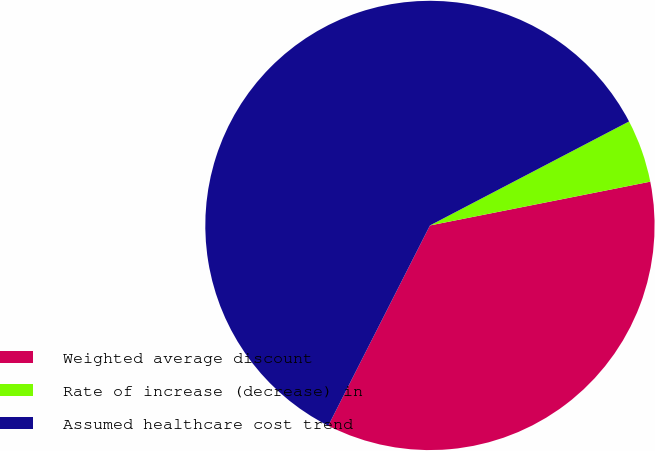Convert chart. <chart><loc_0><loc_0><loc_500><loc_500><pie_chart><fcel>Weighted average discount<fcel>Rate of increase (decrease) in<fcel>Assumed healthcare cost trend<nl><fcel>35.6%<fcel>4.54%<fcel>59.86%<nl></chart> 